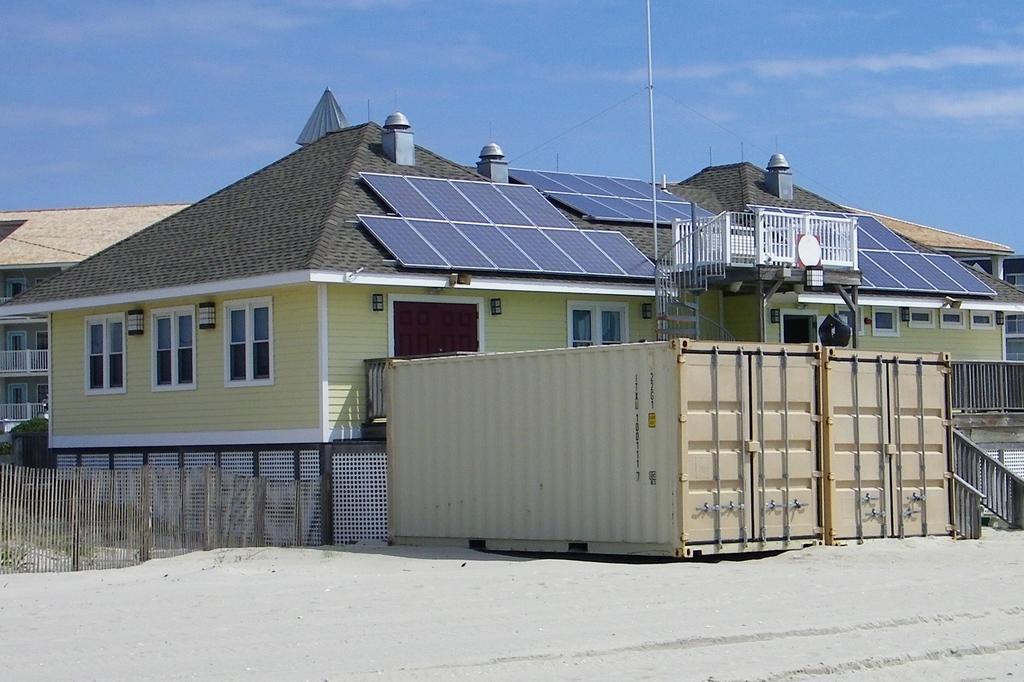Describe this image in one or two sentences. Here in this picture we can see houses present over there and we can also see windows on it and in the front we can see containers present and on the roof we can see solar panels present over there and we can also see clouds in the sky over there. 